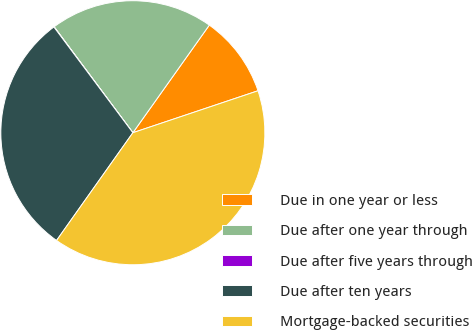<chart> <loc_0><loc_0><loc_500><loc_500><pie_chart><fcel>Due in one year or less<fcel>Due after one year through<fcel>Due after five years through<fcel>Due after ten years<fcel>Mortgage-backed securities<nl><fcel>10.02%<fcel>20.0%<fcel>0.04%<fcel>29.98%<fcel>39.96%<nl></chart> 